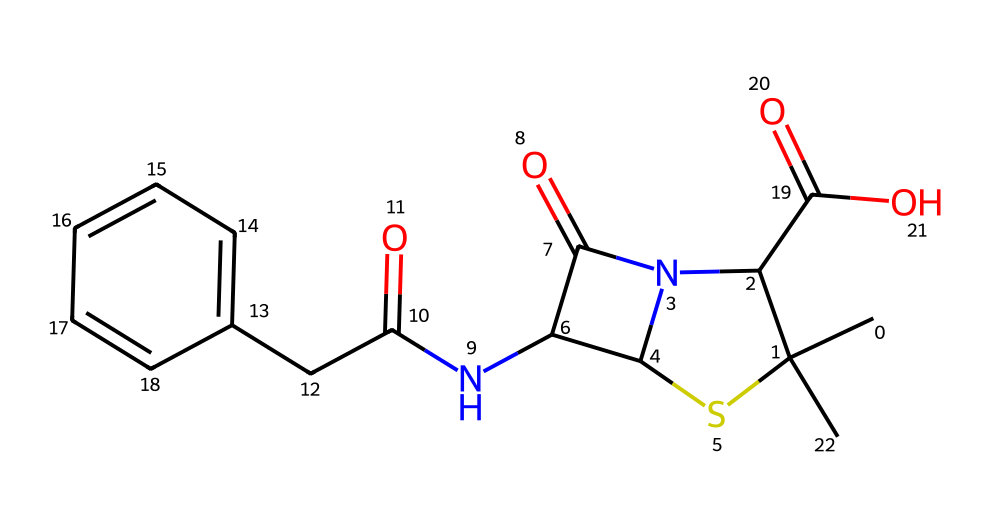What is the molecular formula of this compound? To find the molecular formula, count the carbon, hydrogen, nitrogen, oxygen, and sulfur atoms in the structure. There are 14 carbon atoms, 17 hydrogen atoms, 2 nitrogen atoms, 4 oxygen atoms, and 1 sulfur atom. Thus, the formula is C14H17N2O4S.
Answer: C14H17N2O4S How many rings are present in the structure? Upon examining the structure, it is evident that there are two cyclic components: one is a β-lactam ring and the other is a thiazolidine ring structure. Therefore, the total number of rings is two.
Answer: 2 Which element is present in the sulfonamide part of the structure? The sulfonamide functional group is characterized by the presence of sulfur, which serves as the central atom in this functional portion of the molecule.
Answer: sulfur What type of bonding is primarily present in the structure? The compound consists mainly of covalent bonds, given its organic composition and the sharing of electrons between nonmetals such as carbon, nitrogen, oxygen, and sulfur.
Answer: covalent What functional group is indicated by the presence of "NC(=O)" in the structure? The "NC(=O)" notation identifies an amide functional group, where carbon is bonded to a nitrogen and has a carbonyl group (C=O) attached. This signifies the presence of amide linkages in the compound.
Answer: amide How does the sulfur atom affect the properties of penicillin? The presence of sulfur in the organosulfur compound contributes to unique properties such as antibacterial activity and altering the reactivity of the molecule, enhancing its ability to inhibit bacterial cell wall synthesis.
Answer: antibacterial activity 